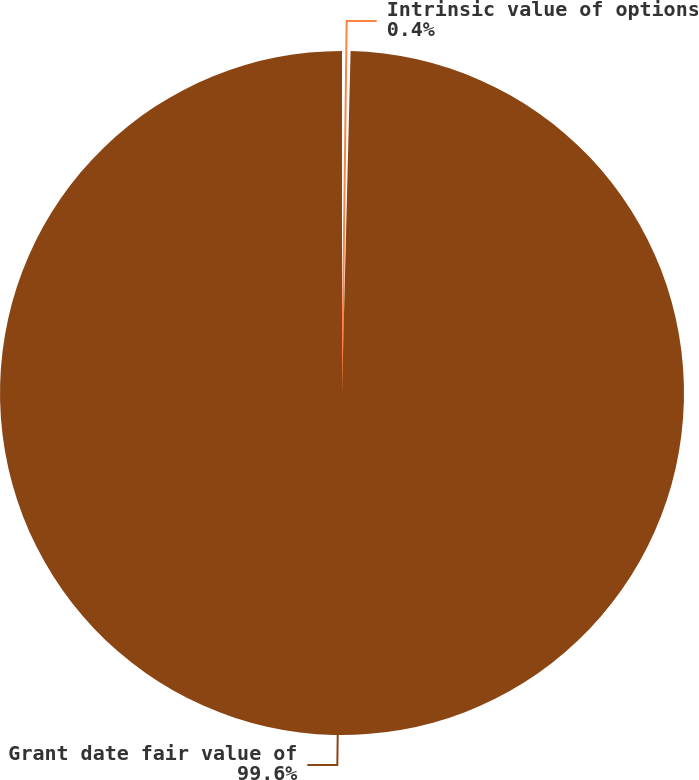<chart> <loc_0><loc_0><loc_500><loc_500><pie_chart><fcel>Intrinsic value of options<fcel>Grant date fair value of<nl><fcel>0.4%<fcel>99.6%<nl></chart> 